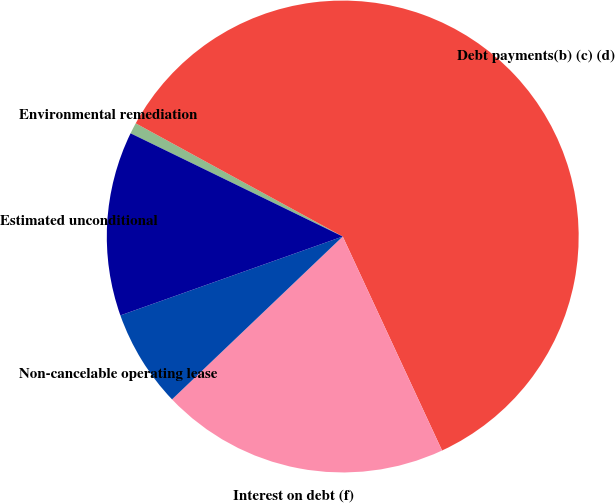Convert chart. <chart><loc_0><loc_0><loc_500><loc_500><pie_chart><fcel>Environmental remediation<fcel>Debt payments(b) (c) (d)<fcel>Interest on debt (f)<fcel>Non-cancelable operating lease<fcel>Estimated unconditional<nl><fcel>0.76%<fcel>60.12%<fcel>19.79%<fcel>6.7%<fcel>12.63%<nl></chart> 